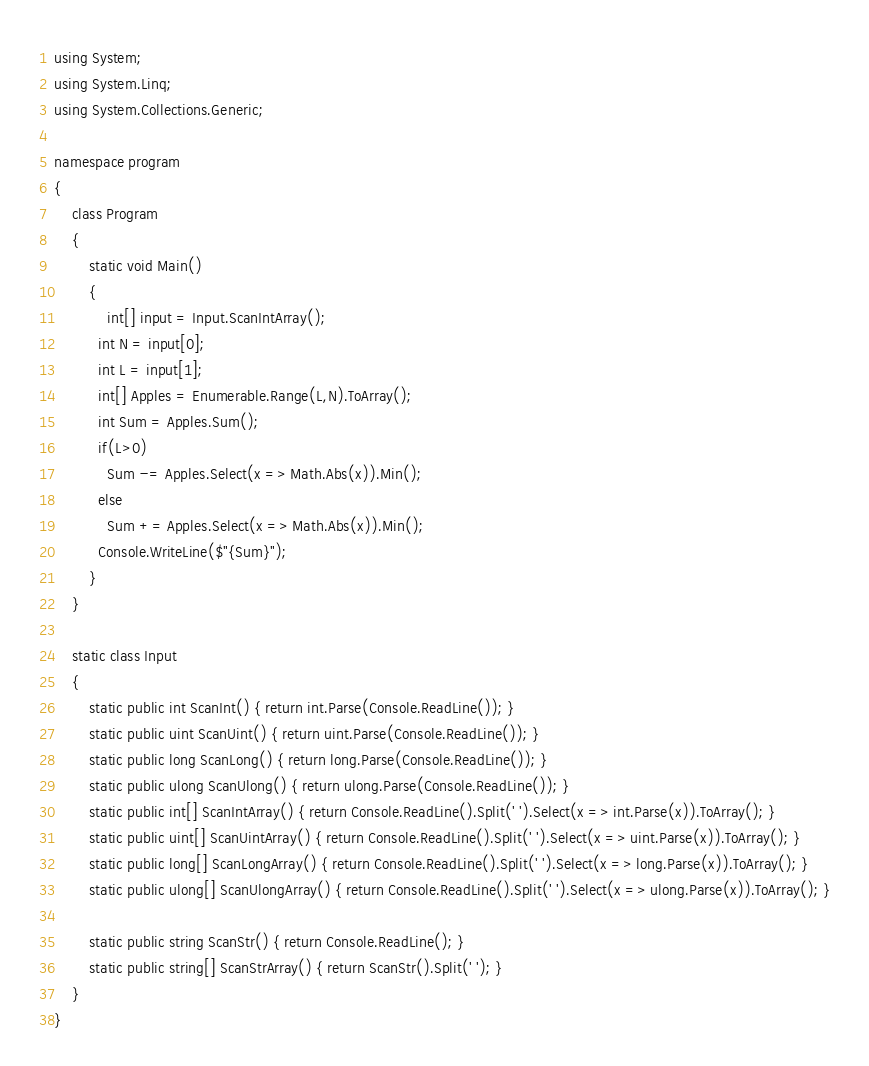<code> <loc_0><loc_0><loc_500><loc_500><_C#_>using System;
using System.Linq;
using System.Collections.Generic;

namespace program
{
    class Program
    {
        static void Main()
        {
            int[] input = Input.ScanIntArray();
          int N = input[0];
          int L = input[1];
          int[] Apples = Enumerable.Range(L,N).ToArray();
          int Sum = Apples.Sum();
          if(L>0)
            Sum -= Apples.Select(x => Math.Abs(x)).Min();
          else
            Sum += Apples.Select(x => Math.Abs(x)).Min();
          Console.WriteLine($"{Sum}");
        }
    }

    static class Input
    {
        static public int ScanInt() { return int.Parse(Console.ReadLine()); }
        static public uint ScanUint() { return uint.Parse(Console.ReadLine()); }
        static public long ScanLong() { return long.Parse(Console.ReadLine()); }
        static public ulong ScanUlong() { return ulong.Parse(Console.ReadLine()); }
        static public int[] ScanIntArray() { return Console.ReadLine().Split(' ').Select(x => int.Parse(x)).ToArray(); }
        static public uint[] ScanUintArray() { return Console.ReadLine().Split(' ').Select(x => uint.Parse(x)).ToArray(); }
        static public long[] ScanLongArray() { return Console.ReadLine().Split(' ').Select(x => long.Parse(x)).ToArray(); }
        static public ulong[] ScanUlongArray() { return Console.ReadLine().Split(' ').Select(x => ulong.Parse(x)).ToArray(); }

        static public string ScanStr() { return Console.ReadLine(); }
        static public string[] ScanStrArray() { return ScanStr().Split(' '); }
    }
}
</code> 